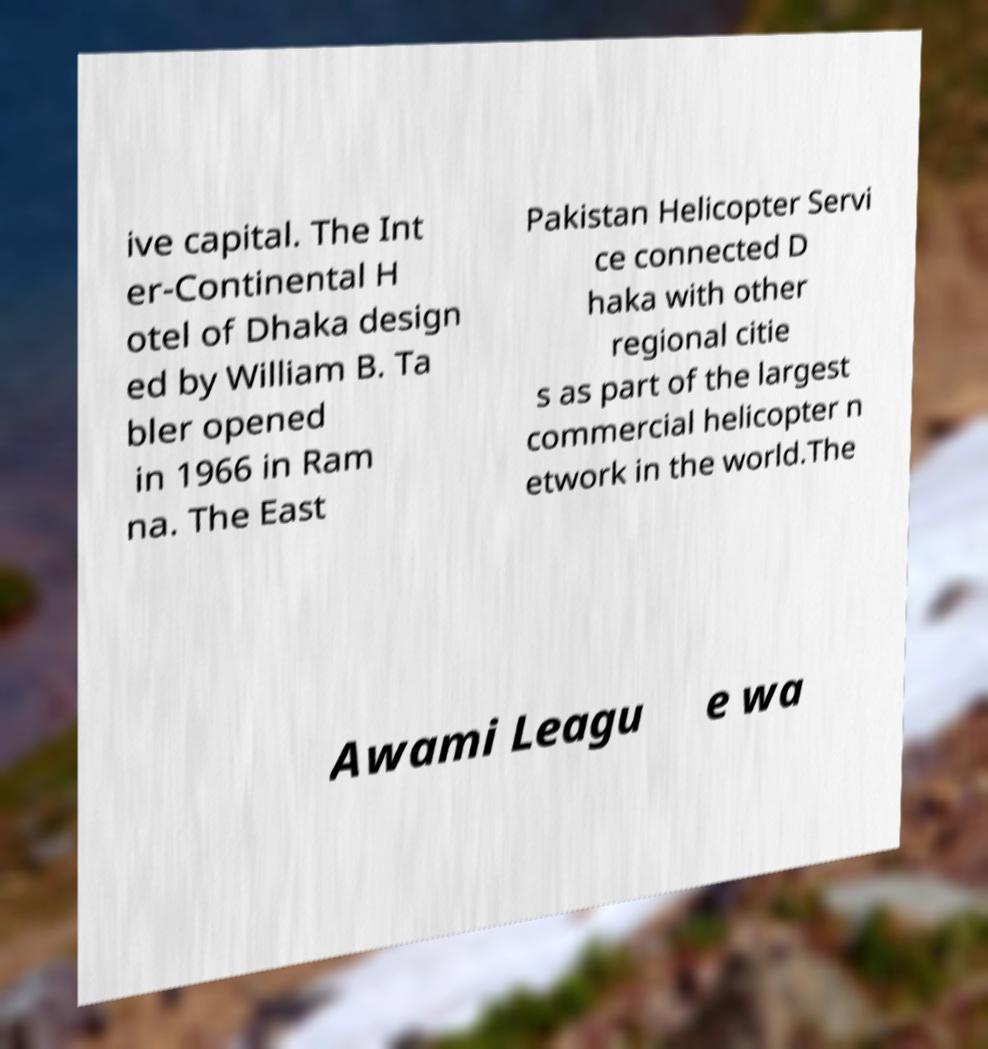Can you accurately transcribe the text from the provided image for me? ive capital. The Int er-Continental H otel of Dhaka design ed by William B. Ta bler opened in 1966 in Ram na. The East Pakistan Helicopter Servi ce connected D haka with other regional citie s as part of the largest commercial helicopter n etwork in the world.The Awami Leagu e wa 